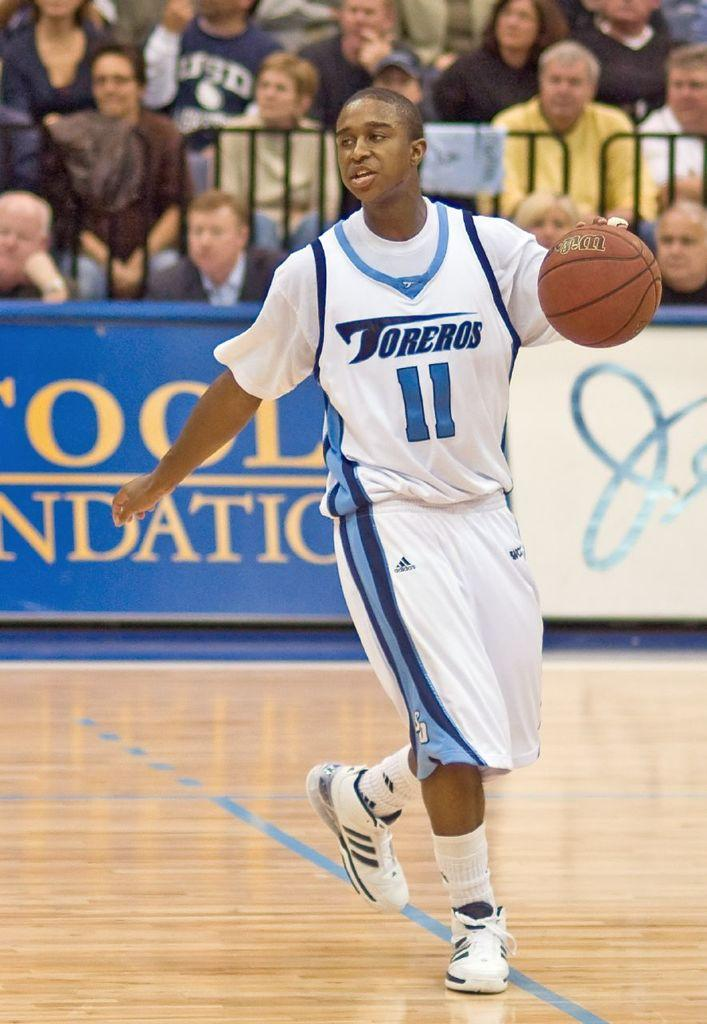<image>
Relay a brief, clear account of the picture shown. A basketball player has an 11 on his jersey. 